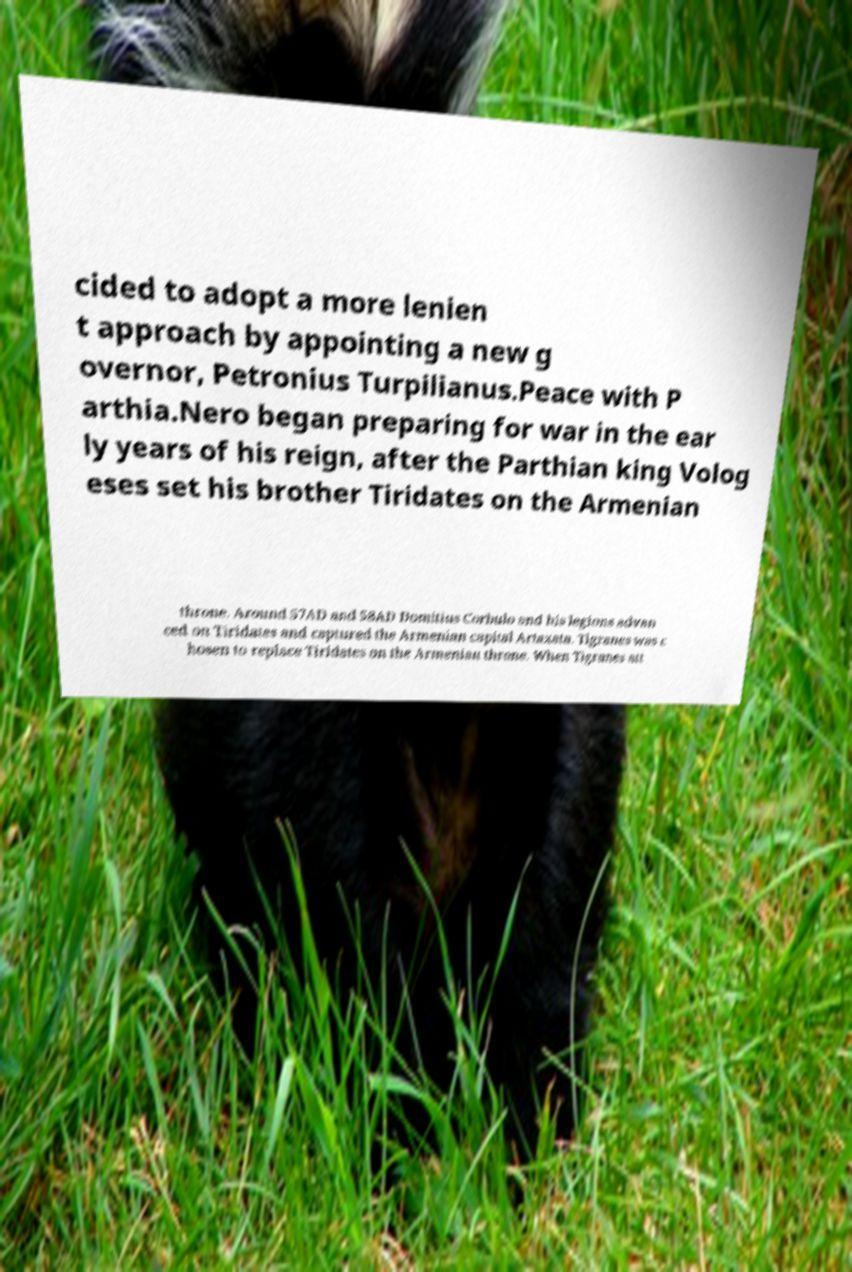I need the written content from this picture converted into text. Can you do that? cided to adopt a more lenien t approach by appointing a new g overnor, Petronius Turpilianus.Peace with P arthia.Nero began preparing for war in the ear ly years of his reign, after the Parthian king Volog eses set his brother Tiridates on the Armenian throne. Around 57AD and 58AD Domitius Corbulo and his legions advan ced on Tiridates and captured the Armenian capital Artaxata. Tigranes was c hosen to replace Tiridates on the Armenian throne. When Tigranes att 